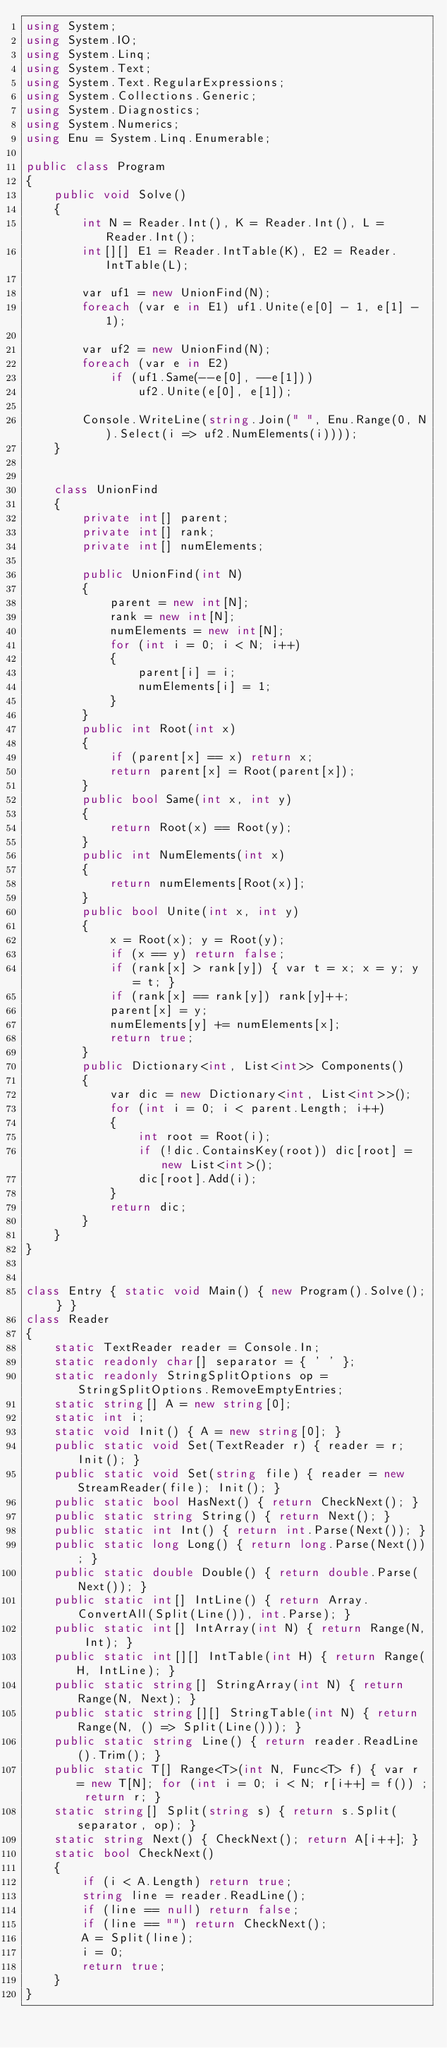Convert code to text. <code><loc_0><loc_0><loc_500><loc_500><_C#_>using System;
using System.IO;
using System.Linq;
using System.Text;
using System.Text.RegularExpressions;
using System.Collections.Generic;
using System.Diagnostics;
using System.Numerics;
using Enu = System.Linq.Enumerable;

public class Program
{
    public void Solve()
    {
        int N = Reader.Int(), K = Reader.Int(), L = Reader.Int();
        int[][] E1 = Reader.IntTable(K), E2 = Reader.IntTable(L);

        var uf1 = new UnionFind(N);
        foreach (var e in E1) uf1.Unite(e[0] - 1, e[1] - 1);

        var uf2 = new UnionFind(N);
        foreach (var e in E2)
            if (uf1.Same(--e[0], --e[1]))
                uf2.Unite(e[0], e[1]);

        Console.WriteLine(string.Join(" ", Enu.Range(0, N).Select(i => uf2.NumElements(i))));
    }


    class UnionFind
    {
        private int[] parent;
        private int[] rank;
        private int[] numElements;

        public UnionFind(int N)
        {
            parent = new int[N];
            rank = new int[N];
            numElements = new int[N];
            for (int i = 0; i < N; i++)
            {
                parent[i] = i;
                numElements[i] = 1;
            }
        }
        public int Root(int x)
        {
            if (parent[x] == x) return x;
            return parent[x] = Root(parent[x]);
        }
        public bool Same(int x, int y)
        {
            return Root(x) == Root(y);
        }
        public int NumElements(int x)
        {
            return numElements[Root(x)];
        }
        public bool Unite(int x, int y)
        {
            x = Root(x); y = Root(y);
            if (x == y) return false;
            if (rank[x] > rank[y]) { var t = x; x = y; y = t; }
            if (rank[x] == rank[y]) rank[y]++;
            parent[x] = y;
            numElements[y] += numElements[x];
            return true;
        }
        public Dictionary<int, List<int>> Components()
        {
            var dic = new Dictionary<int, List<int>>();
            for (int i = 0; i < parent.Length; i++)
            {
                int root = Root(i);
                if (!dic.ContainsKey(root)) dic[root] = new List<int>();
                dic[root].Add(i);
            }
            return dic;
        }
    }
}


class Entry { static void Main() { new Program().Solve(); } }
class Reader
{
    static TextReader reader = Console.In;
    static readonly char[] separator = { ' ' };
    static readonly StringSplitOptions op = StringSplitOptions.RemoveEmptyEntries;
    static string[] A = new string[0];
    static int i;
    static void Init() { A = new string[0]; }
    public static void Set(TextReader r) { reader = r; Init(); }
    public static void Set(string file) { reader = new StreamReader(file); Init(); }
    public static bool HasNext() { return CheckNext(); }
    public static string String() { return Next(); }
    public static int Int() { return int.Parse(Next()); }
    public static long Long() { return long.Parse(Next()); }
    public static double Double() { return double.Parse(Next()); }
    public static int[] IntLine() { return Array.ConvertAll(Split(Line()), int.Parse); }
    public static int[] IntArray(int N) { return Range(N, Int); }
    public static int[][] IntTable(int H) { return Range(H, IntLine); }
    public static string[] StringArray(int N) { return Range(N, Next); }
    public static string[][] StringTable(int N) { return Range(N, () => Split(Line())); }
    public static string Line() { return reader.ReadLine().Trim(); }
    public static T[] Range<T>(int N, Func<T> f) { var r = new T[N]; for (int i = 0; i < N; r[i++] = f()) ; return r; }
    static string[] Split(string s) { return s.Split(separator, op); }
    static string Next() { CheckNext(); return A[i++]; }
    static bool CheckNext()
    {
        if (i < A.Length) return true;
        string line = reader.ReadLine();
        if (line == null) return false;
        if (line == "") return CheckNext();
        A = Split(line);
        i = 0;
        return true;
    }
}</code> 